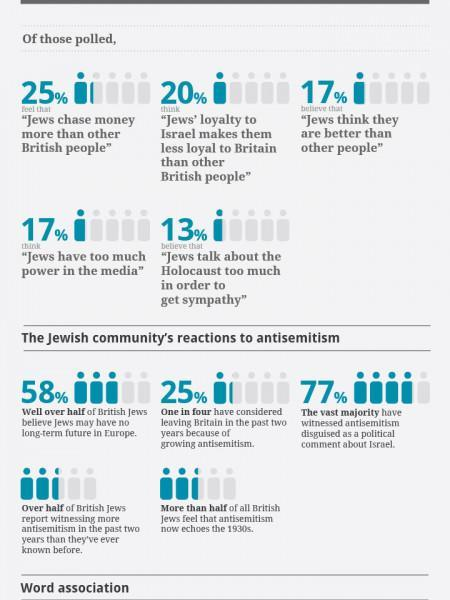how many feel that Jews have too much power in the media
Answer the question with a short phrase. 17% how many feel that Jews are better than other people 17% What % think that Jews do not have a long term future in Europe 58% Jews loyalty to which country is questioned here Britain What % of Jews considered leaving Britain in the past 2 years due to anti-semitism 25% 